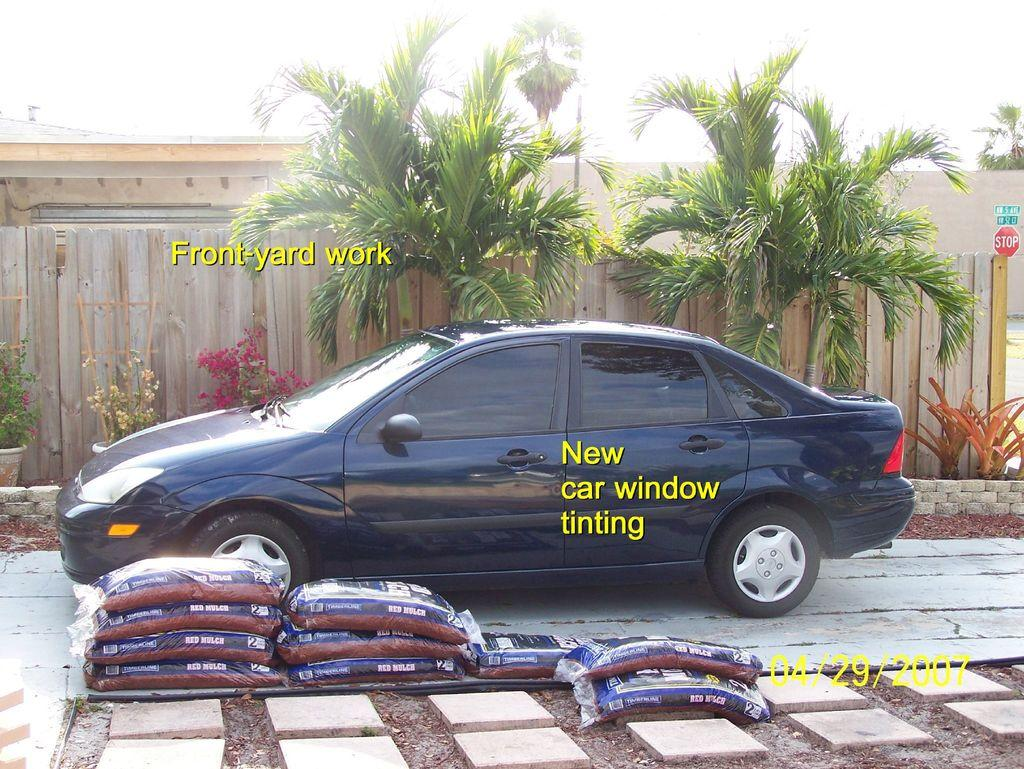What is the main subject in the image? There is a vehicle in the image. What can be seen on the ground near the vehicle? There are bags and stones on the ground in the image. What is visible in the background of the image? There are plants, wooden sticks, a wall, and trees in the background of the image. Can you describe any text visible in the image? Yes, there is some text visible in the image. Is there any blood visible on the vehicle in the image? No, there is no blood visible on the vehicle in the image. Can you see any animals biting the wooden sticks in the background? No, there are no animals or biting visible in the image. 